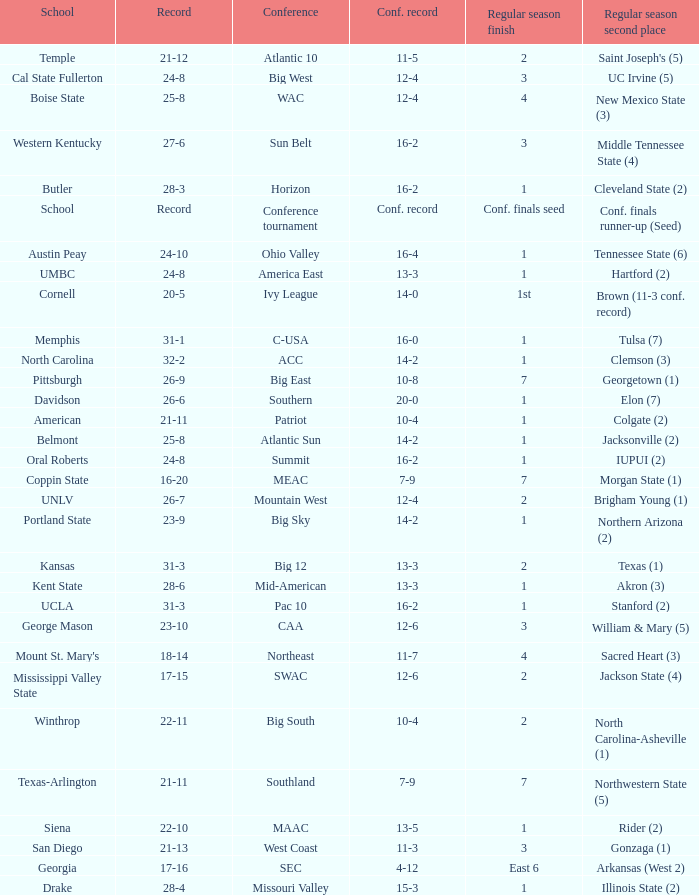Which conference is Belmont in? Atlantic Sun. 